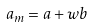Convert formula to latex. <formula><loc_0><loc_0><loc_500><loc_500>a _ { m } = a + w b</formula> 